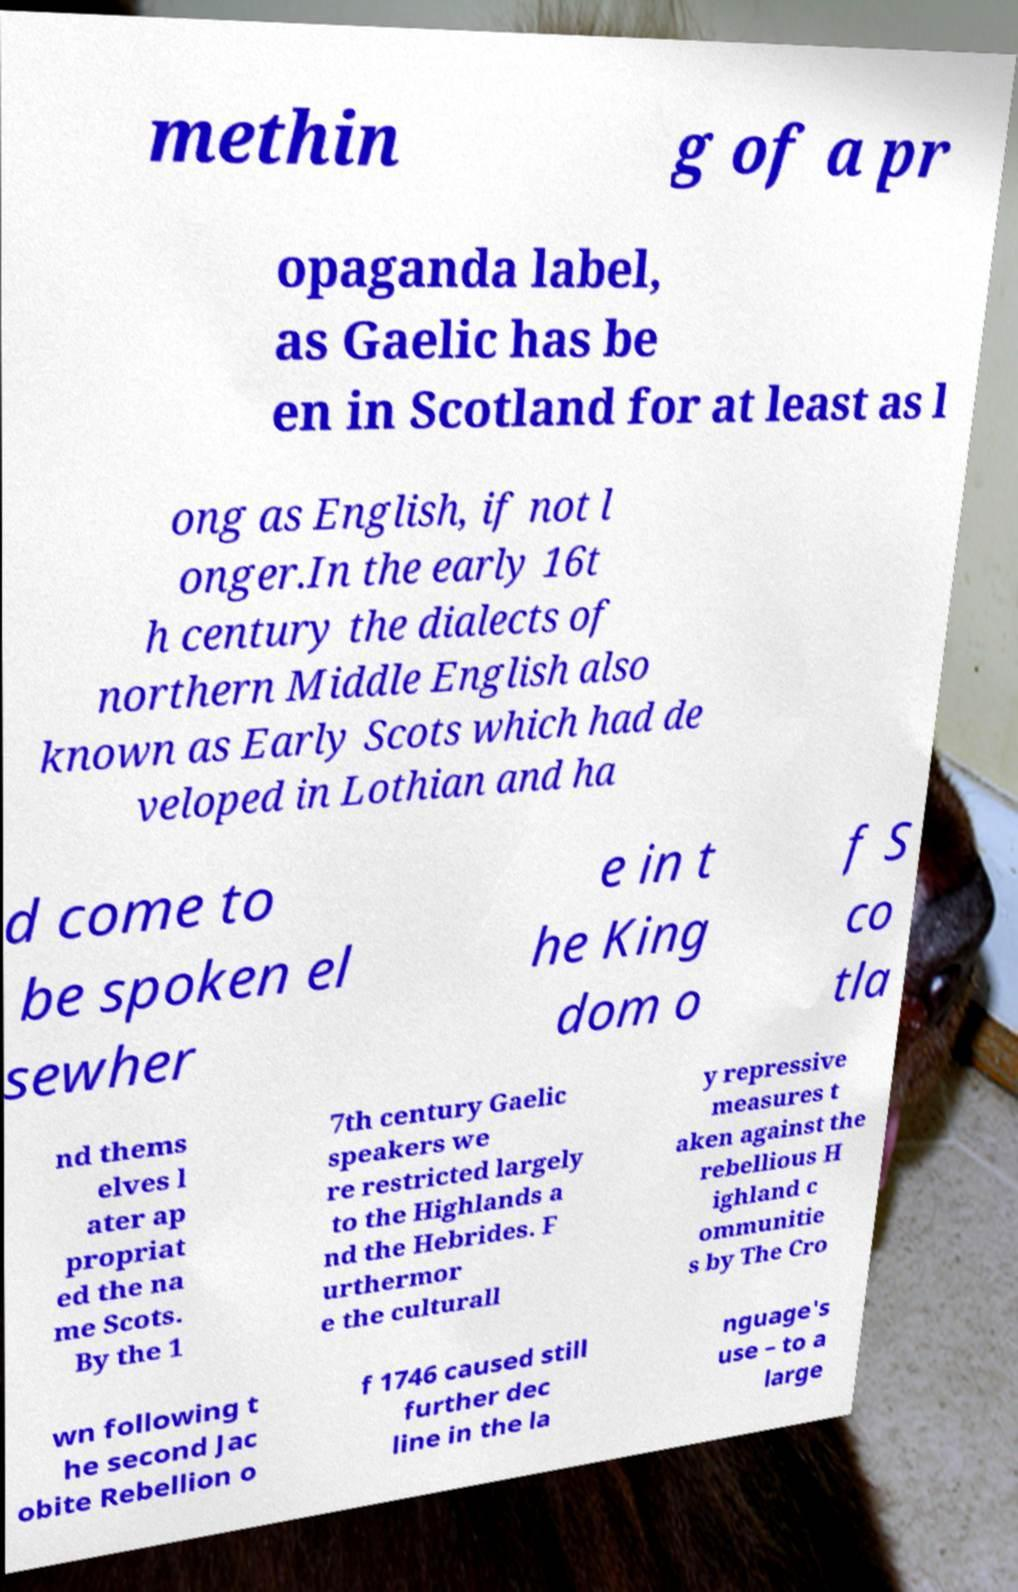For documentation purposes, I need the text within this image transcribed. Could you provide that? methin g of a pr opaganda label, as Gaelic has be en in Scotland for at least as l ong as English, if not l onger.In the early 16t h century the dialects of northern Middle English also known as Early Scots which had de veloped in Lothian and ha d come to be spoken el sewher e in t he King dom o f S co tla nd thems elves l ater ap propriat ed the na me Scots. By the 1 7th century Gaelic speakers we re restricted largely to the Highlands a nd the Hebrides. F urthermor e the culturall y repressive measures t aken against the rebellious H ighland c ommunitie s by The Cro wn following t he second Jac obite Rebellion o f 1746 caused still further dec line in the la nguage's use – to a large 